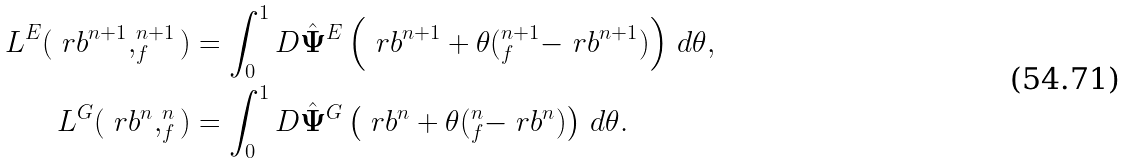<formula> <loc_0><loc_0><loc_500><loc_500>L ^ { E } ( \ r b ^ { n + 1 } , _ { f } ^ { n + 1 } ) & = \int _ { 0 } ^ { 1 } D \hat { \mathbf \Psi } ^ { E } \left ( \ r b ^ { n + 1 } + \theta ( _ { f } ^ { n + 1 } - \ r b ^ { n + 1 } ) \right ) \, d \theta , \\ L ^ { G } ( \ r b ^ { n } , _ { f } ^ { n } ) & = \int _ { 0 } ^ { 1 } D \hat { \mathbf \Psi } ^ { G } \left ( \ r b ^ { n } + \theta ( _ { f } ^ { n } - \ r b ^ { n } ) \right ) \, d \theta .</formula> 